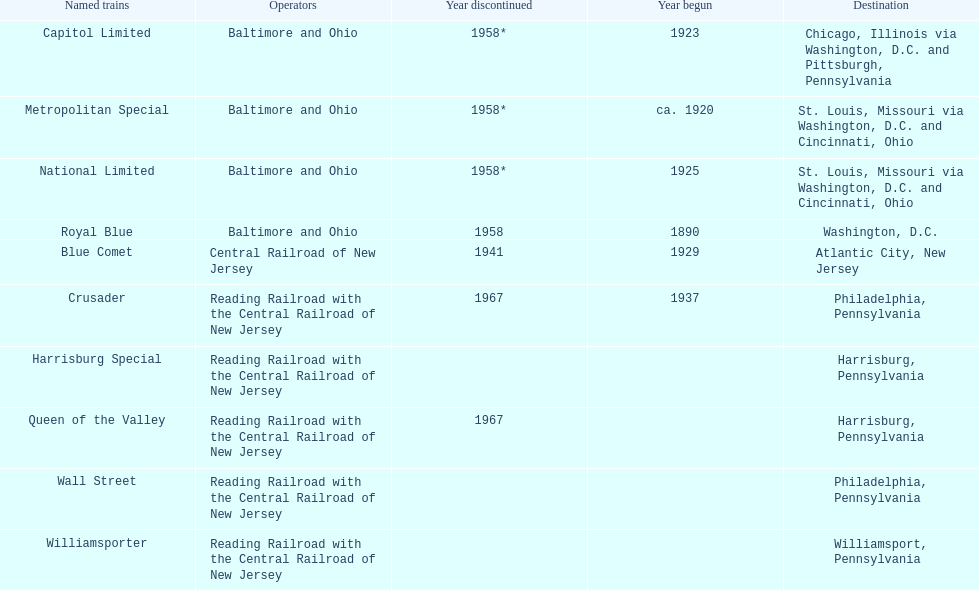What destination is at the top of the list? Chicago, Illinois via Washington, D.C. and Pittsburgh, Pennsylvania. 